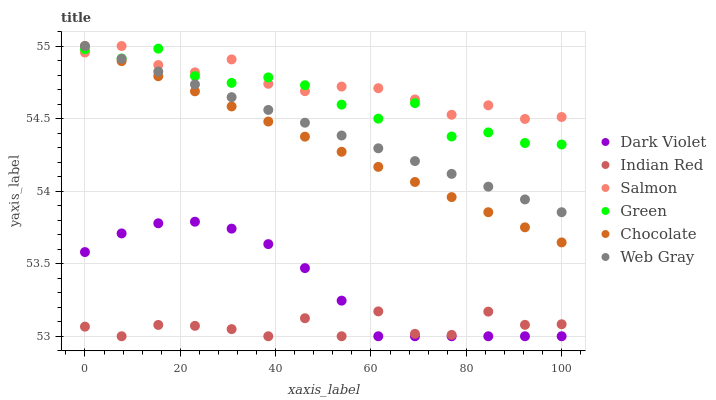Does Indian Red have the minimum area under the curve?
Answer yes or no. Yes. Does Salmon have the maximum area under the curve?
Answer yes or no. Yes. Does Dark Violet have the minimum area under the curve?
Answer yes or no. No. Does Dark Violet have the maximum area under the curve?
Answer yes or no. No. Is Chocolate the smoothest?
Answer yes or no. Yes. Is Indian Red the roughest?
Answer yes or no. Yes. Is Salmon the smoothest?
Answer yes or no. No. Is Salmon the roughest?
Answer yes or no. No. Does Dark Violet have the lowest value?
Answer yes or no. Yes. Does Salmon have the lowest value?
Answer yes or no. No. Does Chocolate have the highest value?
Answer yes or no. Yes. Does Dark Violet have the highest value?
Answer yes or no. No. Is Indian Red less than Chocolate?
Answer yes or no. Yes. Is Chocolate greater than Dark Violet?
Answer yes or no. Yes. Does Web Gray intersect Chocolate?
Answer yes or no. Yes. Is Web Gray less than Chocolate?
Answer yes or no. No. Is Web Gray greater than Chocolate?
Answer yes or no. No. Does Indian Red intersect Chocolate?
Answer yes or no. No. 